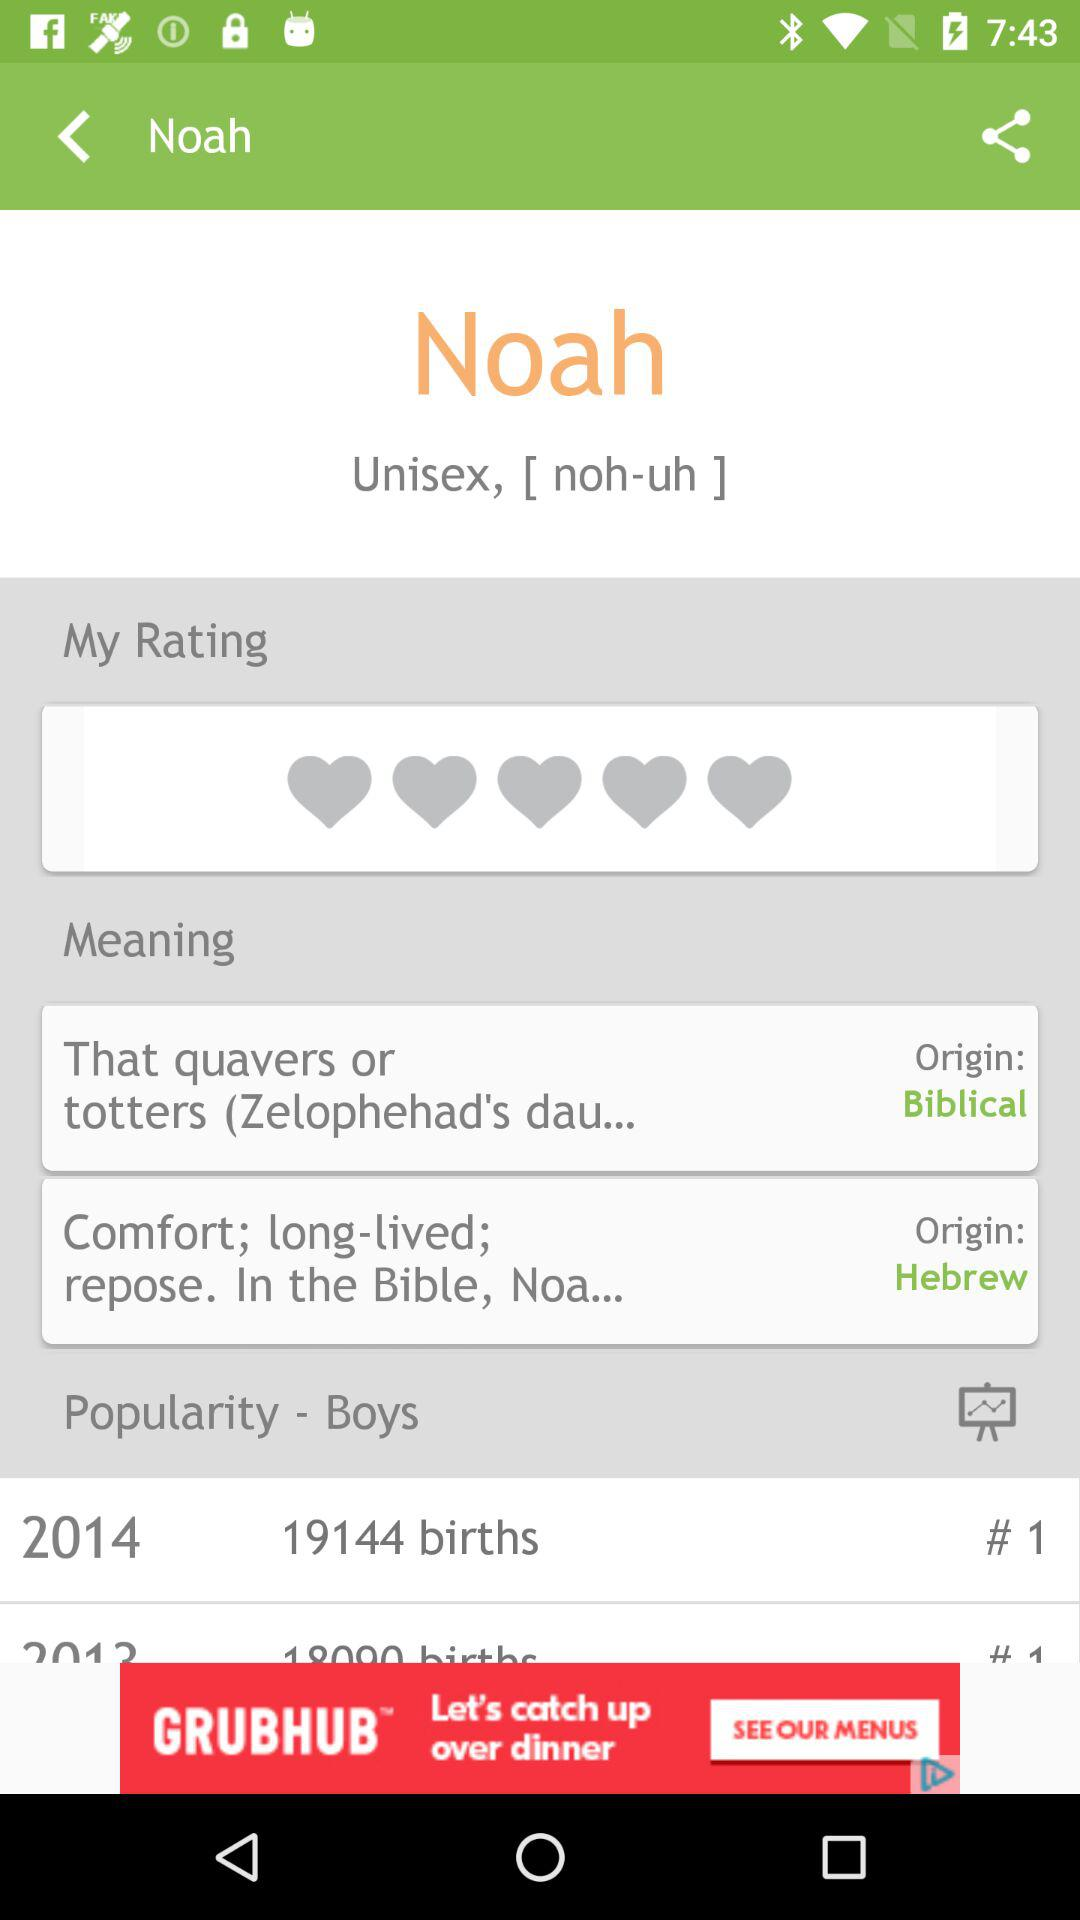How many babies were born in 2014? The babies that were born in 2014 are 19144. 